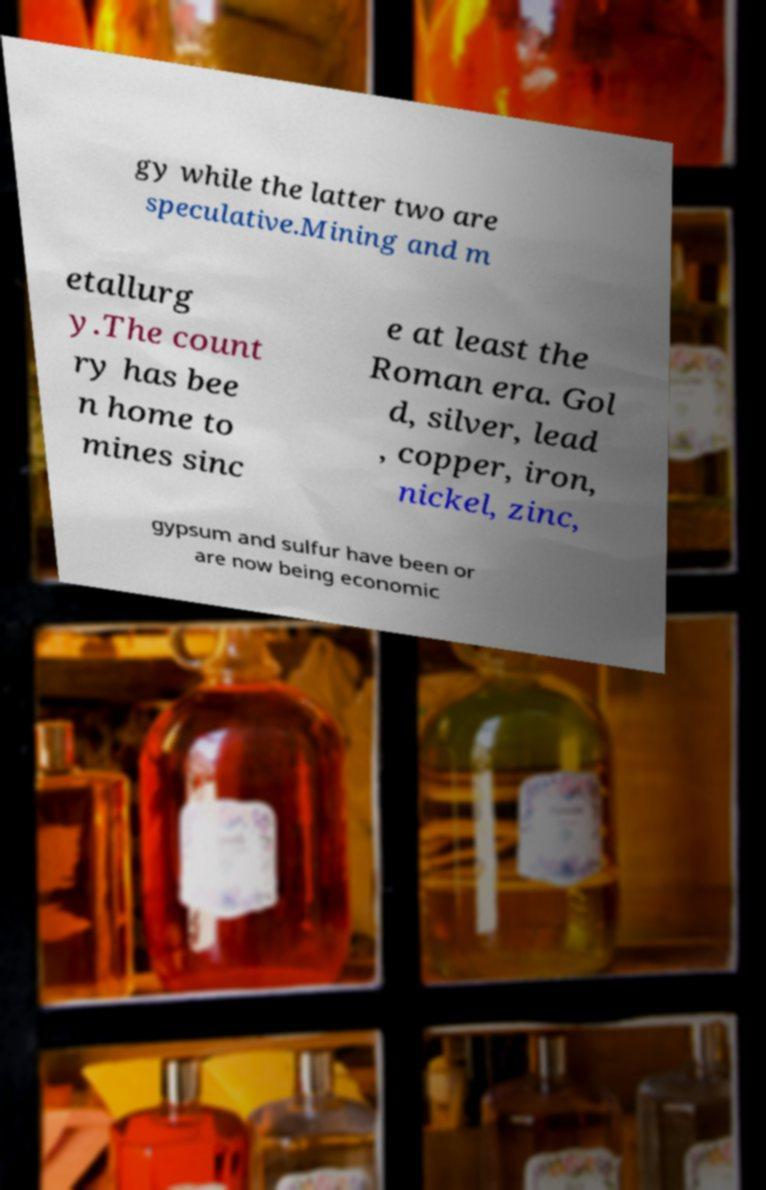I need the written content from this picture converted into text. Can you do that? gy while the latter two are speculative.Mining and m etallurg y.The count ry has bee n home to mines sinc e at least the Roman era. Gol d, silver, lead , copper, iron, nickel, zinc, gypsum and sulfur have been or are now being economic 